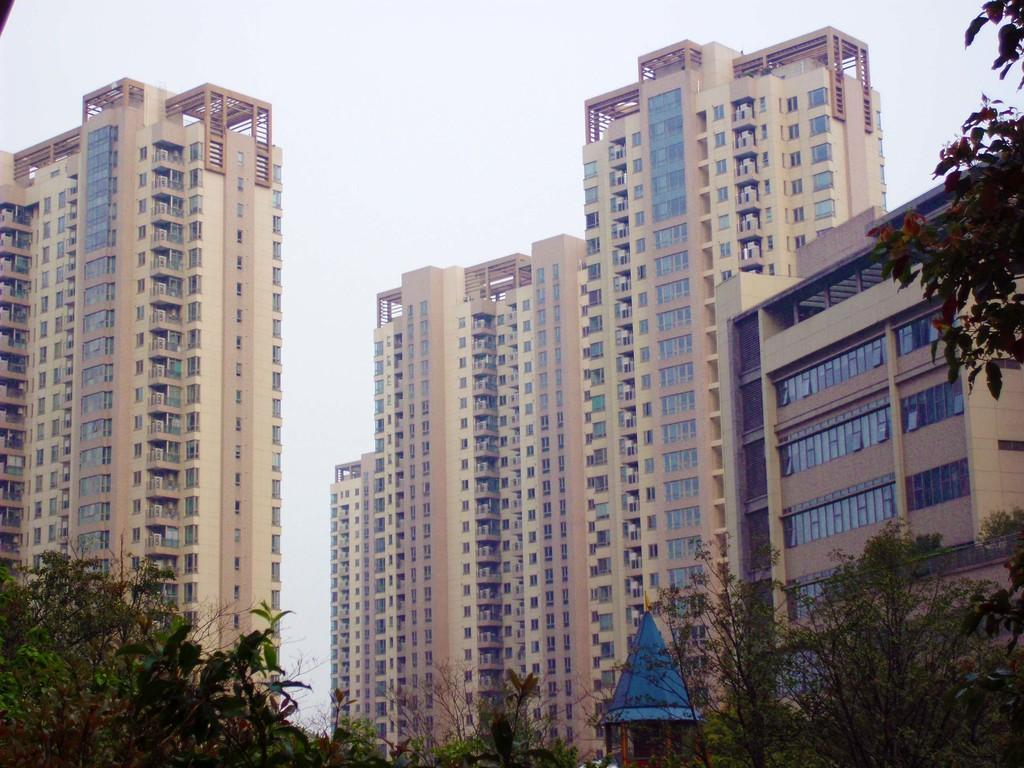What type of structures can be seen in the image? There are buildings in the image. What other natural elements are present in the image? There are trees in the image. What can be seen in the distance in the image? The sky is visible in the background of the image. What type of glove is being used to stir the soup in the image? There is no glove or soup present in the image; it features buildings and trees with the sky visible in the background. 